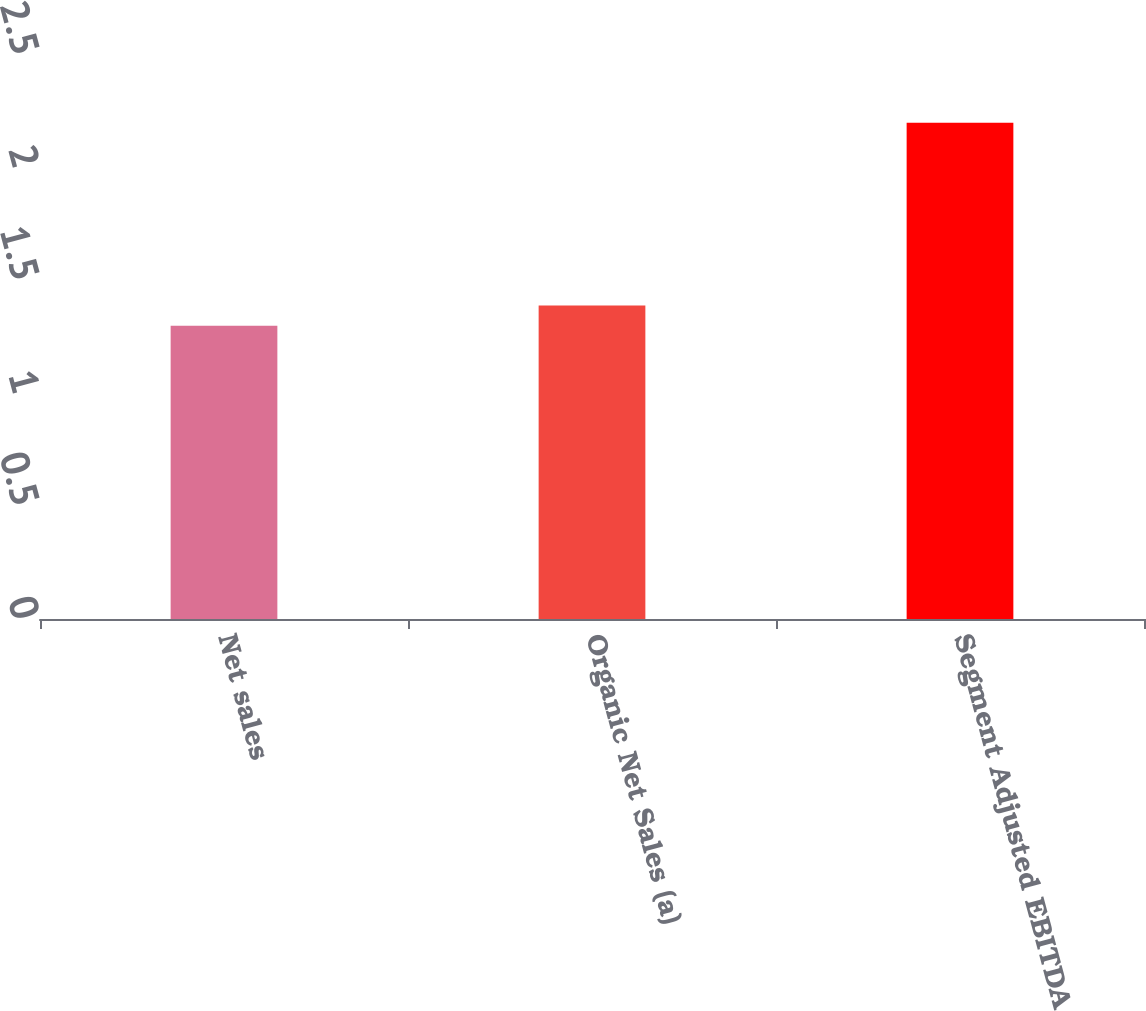<chart> <loc_0><loc_0><loc_500><loc_500><bar_chart><fcel>Net sales<fcel>Organic Net Sales (a)<fcel>Segment Adjusted EBITDA<nl><fcel>1.3<fcel>1.39<fcel>2.2<nl></chart> 